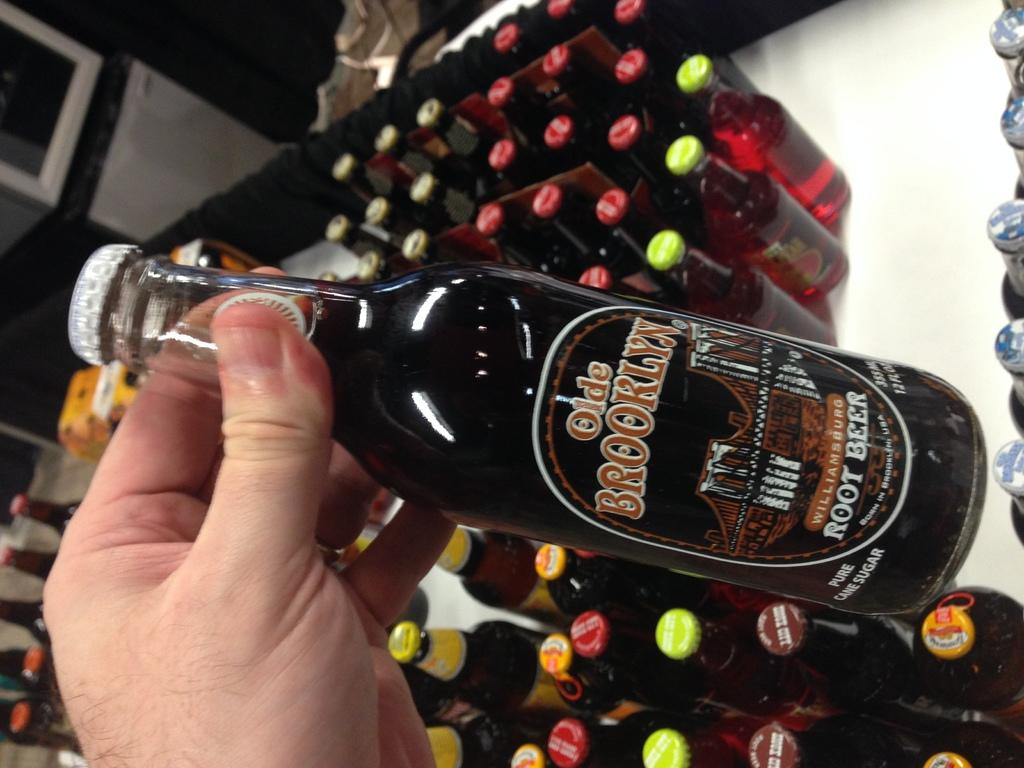Provide a one-sentence caption for the provided image. A bottle of Old Brooklyn Root Beer is being held above other bottles. 